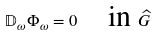Convert formula to latex. <formula><loc_0><loc_0><loc_500><loc_500>\mathbb { D } _ { \omega } \Phi _ { \omega } = 0 \quad \text {in } \widehat { G }</formula> 